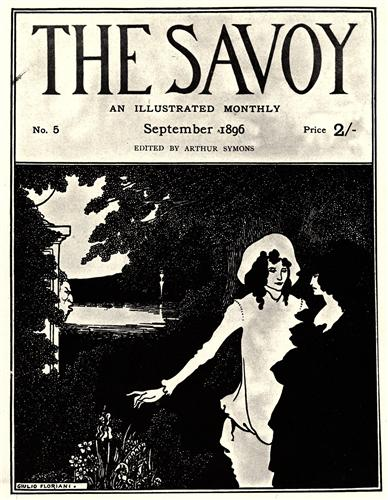What might be the significance of the woman's white dress in this setting? The woman's white dress in the setting likely symbolizes purity, innocence, and a sense of ethereal beauty. In the late 19th century, white was often associated with virtue and maidenhood. The dress stands out against the monochromatic palette of the image, drawing attention to her presence and emphasizing her prominence in the scene. It might also suggest a sense of new beginnings or a fresh start, encapsulating the romantic and serene mood of the moment shared with her companion in the tranquil garden. 